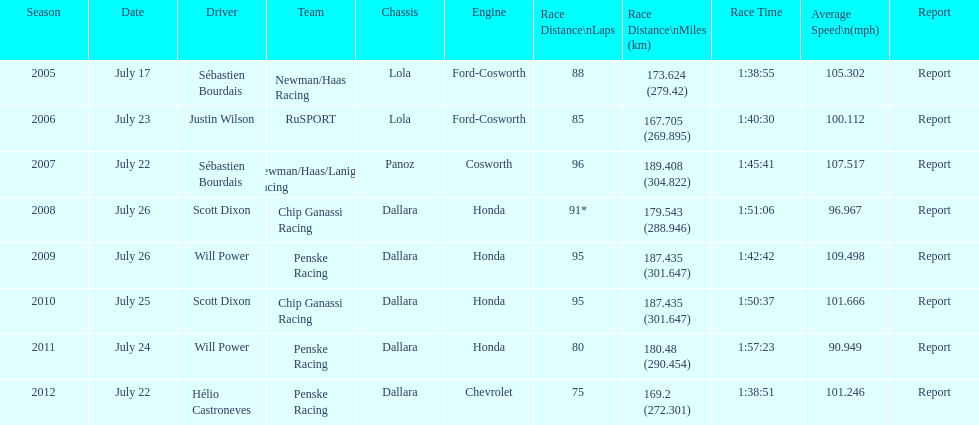Give me the full table as a dictionary. {'header': ['Season', 'Date', 'Driver', 'Team', 'Chassis', 'Engine', 'Race Distance\\nLaps', 'Race Distance\\nMiles (km)', 'Race Time', 'Average Speed\\n(mph)', 'Report'], 'rows': [['2005', 'July 17', 'Sébastien Bourdais', 'Newman/Haas Racing', 'Lola', 'Ford-Cosworth', '88', '173.624 (279.42)', '1:38:55', '105.302', 'Report'], ['2006', 'July 23', 'Justin Wilson', 'RuSPORT', 'Lola', 'Ford-Cosworth', '85', '167.705 (269.895)', '1:40:30', '100.112', 'Report'], ['2007', 'July 22', 'Sébastien Bourdais', 'Newman/Haas/Lanigan Racing', 'Panoz', 'Cosworth', '96', '189.408 (304.822)', '1:45:41', '107.517', 'Report'], ['2008', 'July 26', 'Scott Dixon', 'Chip Ganassi Racing', 'Dallara', 'Honda', '91*', '179.543 (288.946)', '1:51:06', '96.967', 'Report'], ['2009', 'July 26', 'Will Power', 'Penske Racing', 'Dallara', 'Honda', '95', '187.435 (301.647)', '1:42:42', '109.498', 'Report'], ['2010', 'July 25', 'Scott Dixon', 'Chip Ganassi Racing', 'Dallara', 'Honda', '95', '187.435 (301.647)', '1:50:37', '101.666', 'Report'], ['2011', 'July 24', 'Will Power', 'Penske Racing', 'Dallara', 'Honda', '80', '180.48 (290.454)', '1:57:23', '90.949', 'Report'], ['2012', 'July 22', 'Hélio Castroneves', 'Penske Racing', 'Dallara', 'Chevrolet', '75', '169.2 (272.301)', '1:38:51', '101.246', 'Report']]} Which team won the champ car world series the year before rusport? Newman/Haas Racing. 